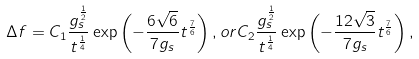Convert formula to latex. <formula><loc_0><loc_0><loc_500><loc_500>\Delta f = C _ { 1 } \frac { g _ { s } ^ { \frac { 1 } { 2 } } } { t ^ { \frac { 1 } { 4 } } } \exp \left ( - \frac { 6 \sqrt { 6 } } { 7 g _ { s } } t ^ { \frac { 7 } { 6 } } \right ) , o r C _ { 2 } \frac { g _ { s } ^ { \frac { 1 } { 2 } } } { t ^ { \frac { 1 } { 4 } } } \exp \left ( - \frac { 1 2 \sqrt { 3 } } { 7 g _ { s } } t ^ { \frac { 7 } { 6 } } \right ) ,</formula> 